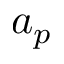Convert formula to latex. <formula><loc_0><loc_0><loc_500><loc_500>a _ { p }</formula> 